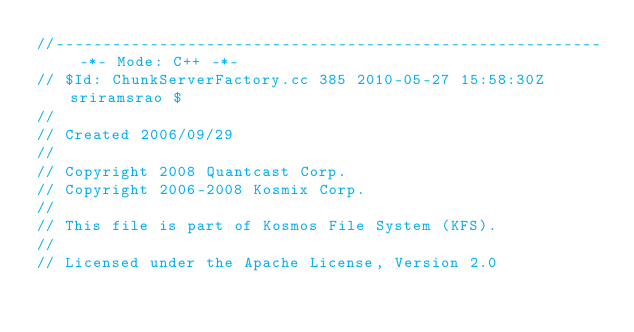Convert code to text. <code><loc_0><loc_0><loc_500><loc_500><_C++_>//---------------------------------------------------------- -*- Mode: C++ -*-
// $Id: ChunkServerFactory.cc 385 2010-05-27 15:58:30Z sriramsrao $
//
// Created 2006/09/29
//
// Copyright 2008 Quantcast Corp.
// Copyright 2006-2008 Kosmix Corp.
//
// This file is part of Kosmos File System (KFS).
//
// Licensed under the Apache License, Version 2.0</code> 